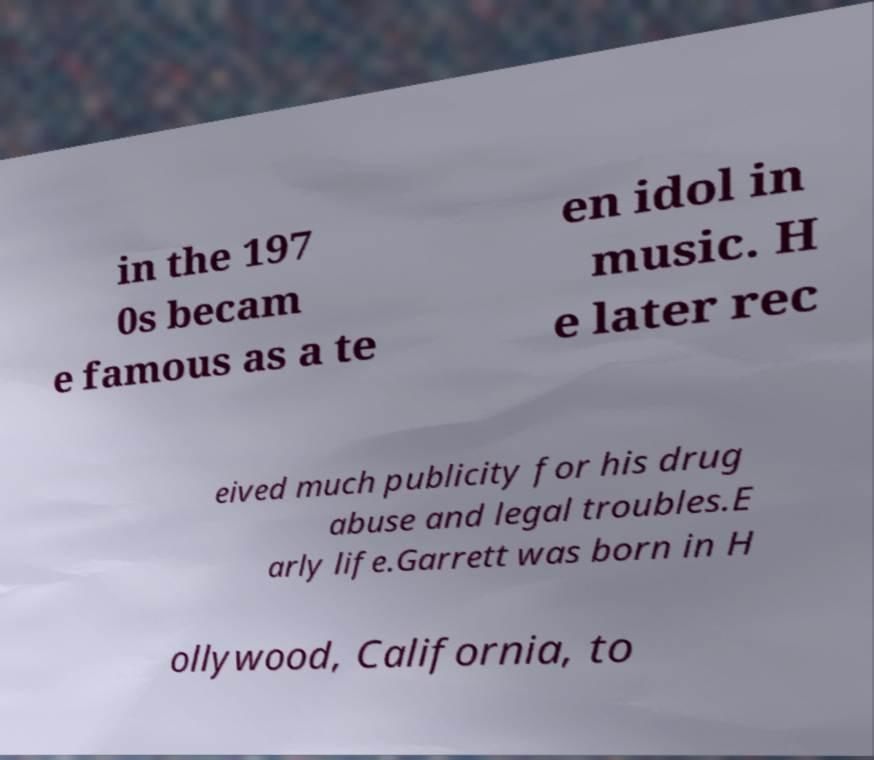Can you accurately transcribe the text from the provided image for me? in the 197 0s becam e famous as a te en idol in music. H e later rec eived much publicity for his drug abuse and legal troubles.E arly life.Garrett was born in H ollywood, California, to 